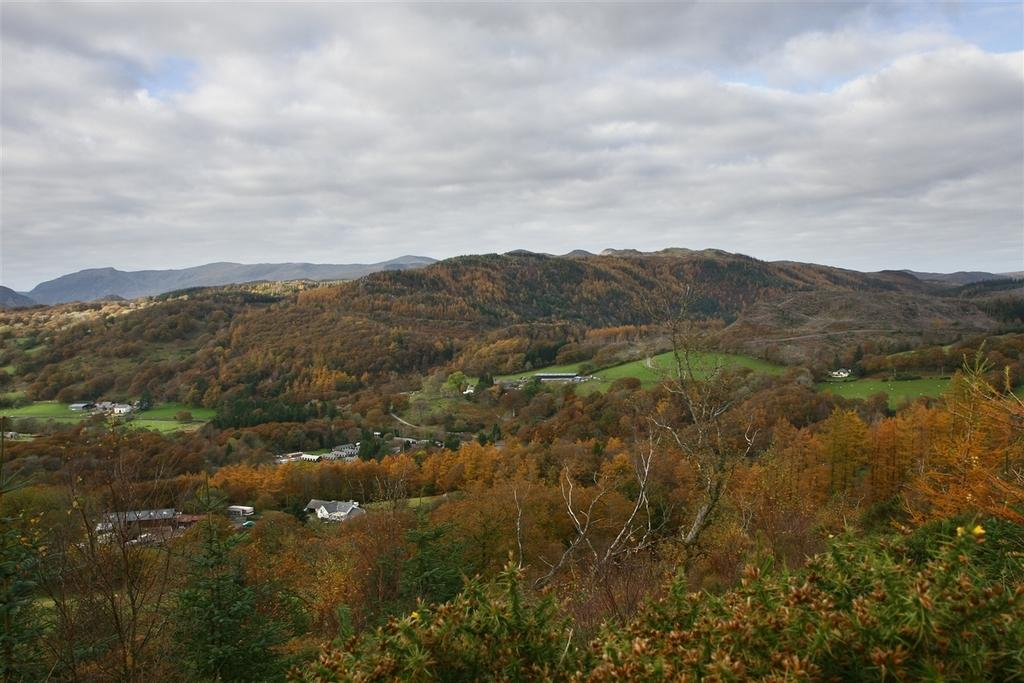What type of landscape is depicted in the image? The image features hills filled with trees. Are there any structures visible in the image? Yes, there are houses in the image. What type of vegetation is present on the hills? Grass iss is present in the image. What can be seen in the sky in the image? The sky is visible in the image, and clouds are present. What is the opinion of the orange about the hills in the image? There is no orange present in the image, and therefore no opinion can be attributed to it. 